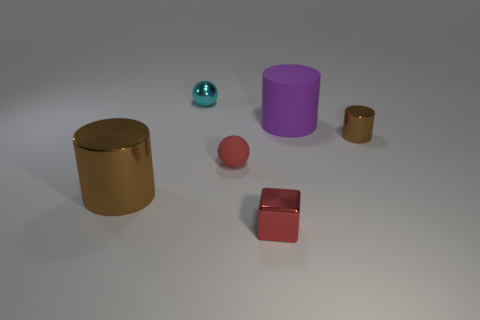If these objects were part of a game, what kind of game could it be? If these objects were part of a game, their varied sizes and colors suggest it could be a sorting or matching game. For instance, players might be tasked with arranging the objects by size or color. Alternatively, these objects could be game pieces in a board game, with each color or shape representing a different player or role. 